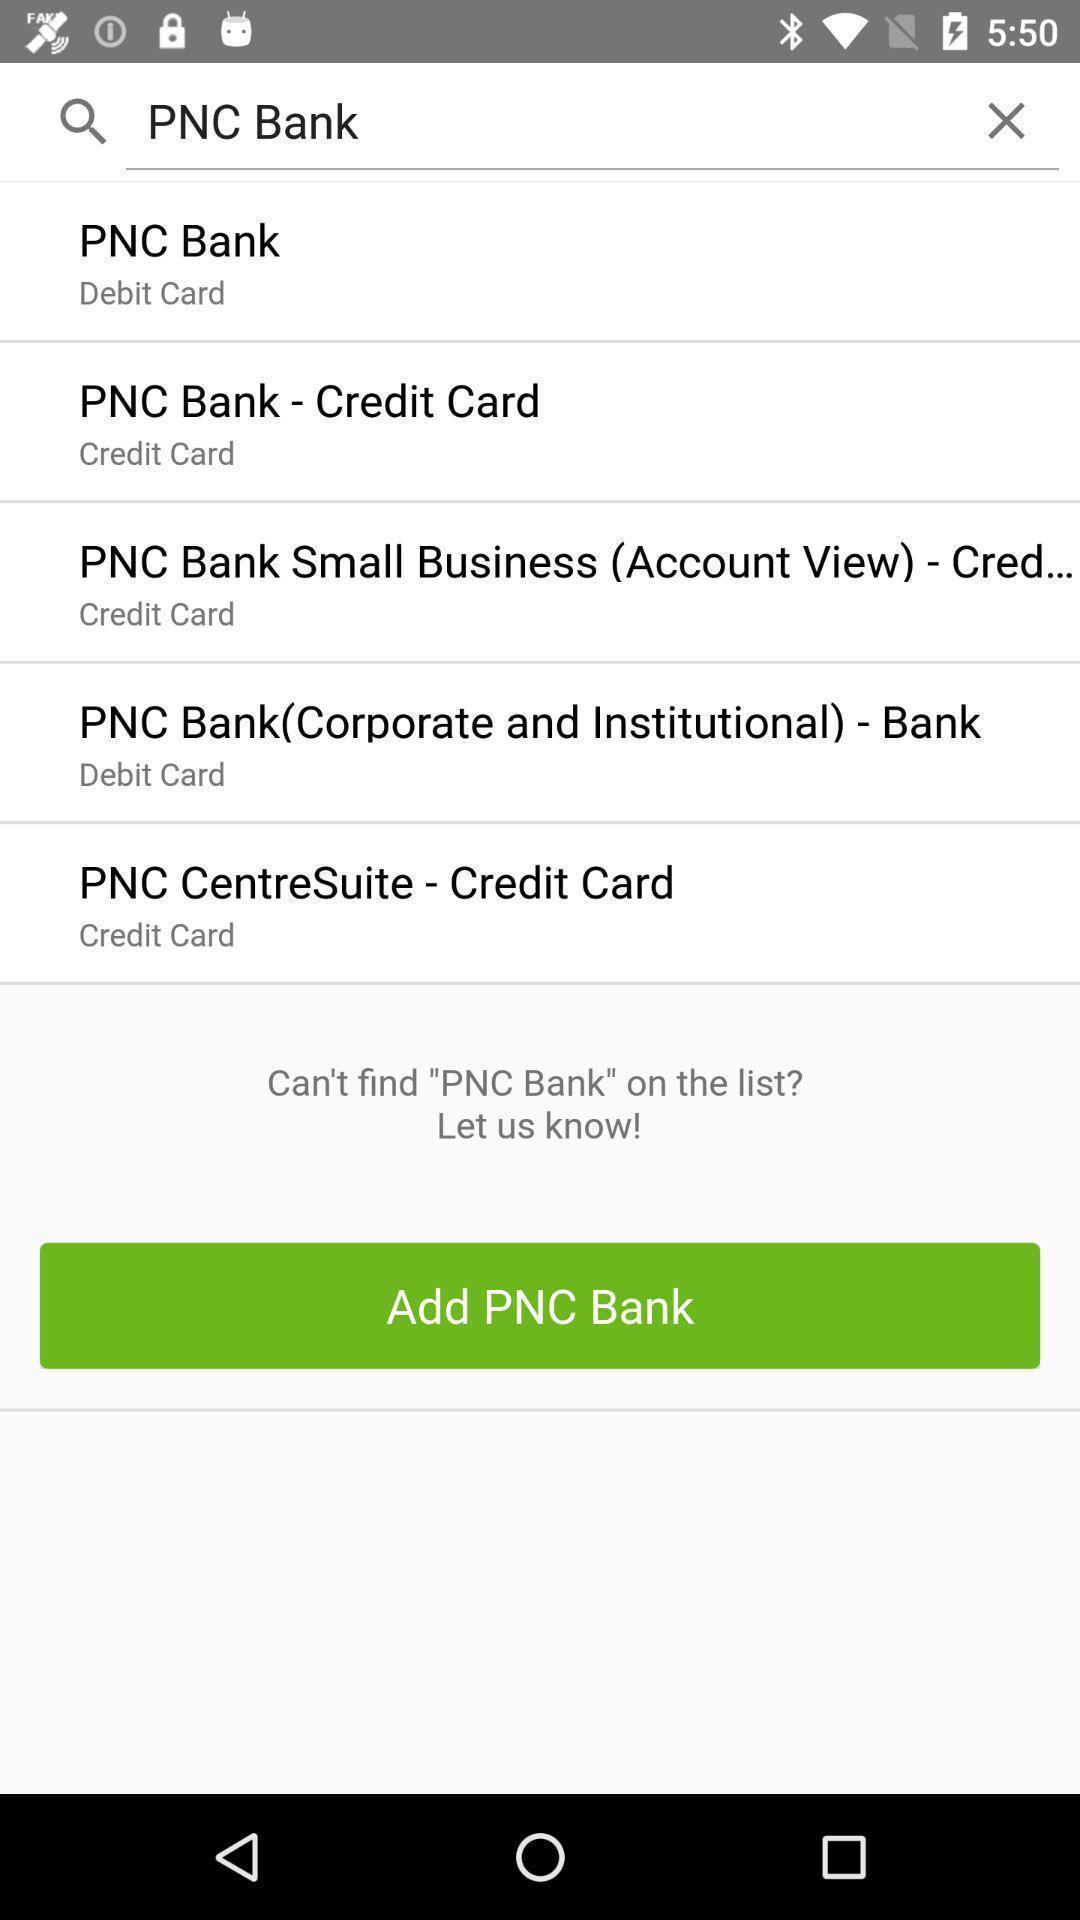Please provide a description for this image. Search page of a banking app. 